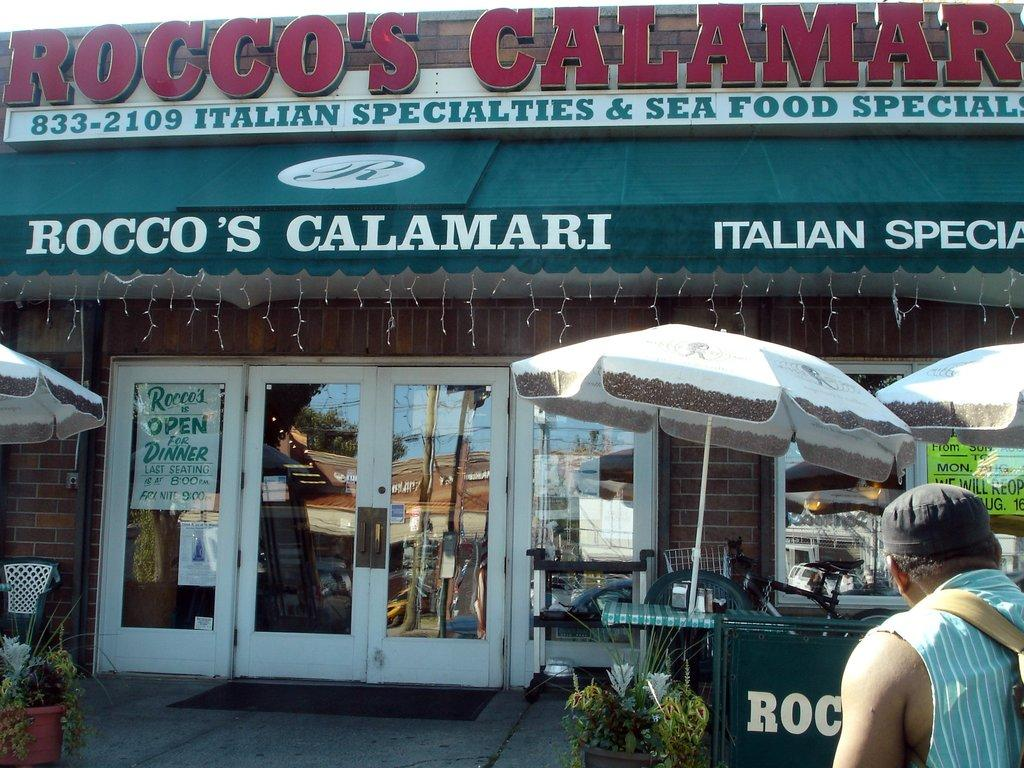What is the main subject of the image? There is a person standing in the image. Can you describe the person's attire? The person is wearing a cap. What is located in front of the person? There is a shop in front of the person. What is hanging above the shop? There is a banner on top of the shop. How many ladybugs can be seen crawling on the person's cap in the image? There are no ladybugs present on the person's cap in the image. What type of hook is attached to the banner in the image? There is no hook visible in the image; only the banner is mentioned. 